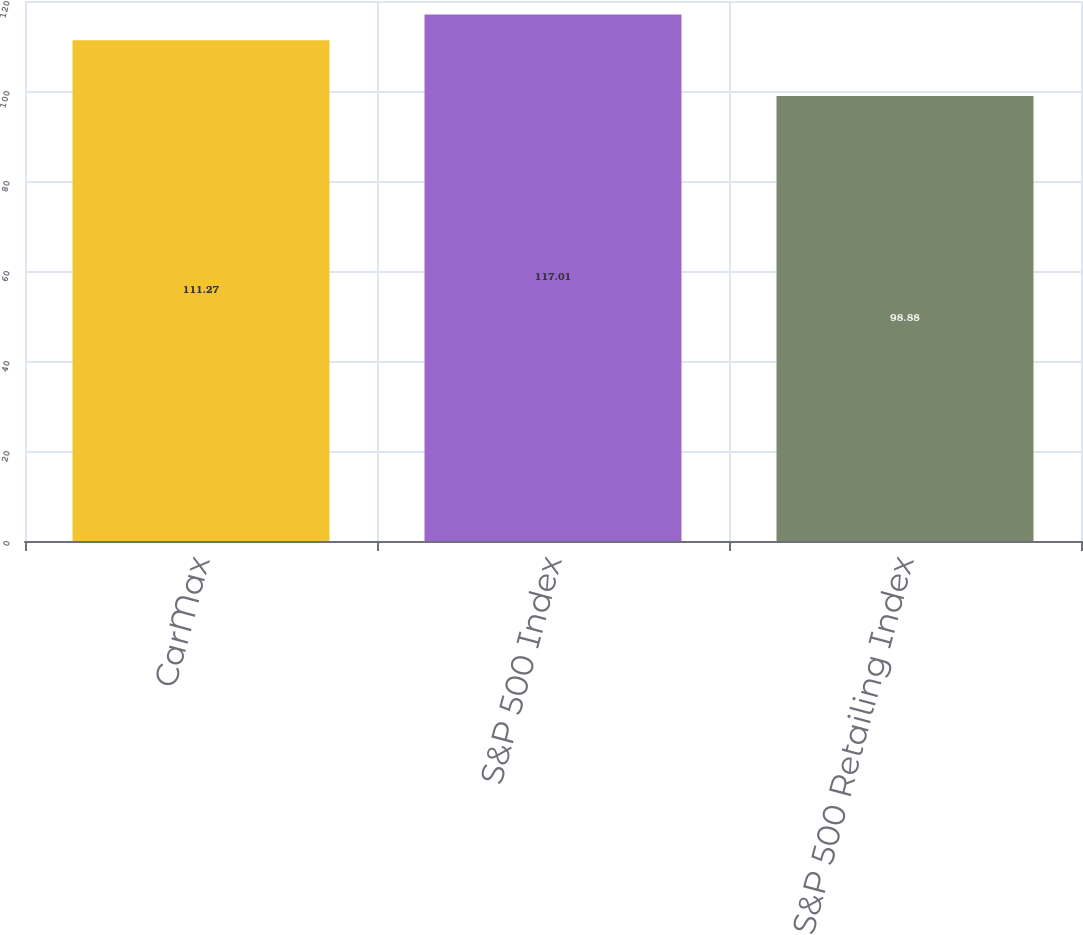Convert chart. <chart><loc_0><loc_0><loc_500><loc_500><bar_chart><fcel>CarMax<fcel>S&P 500 Index<fcel>S&P 500 Retailing Index<nl><fcel>111.27<fcel>117.01<fcel>98.88<nl></chart> 